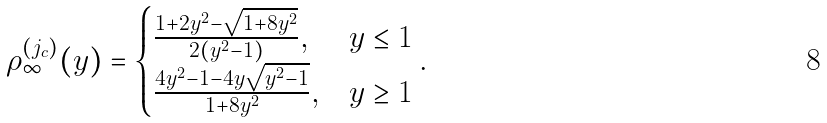<formula> <loc_0><loc_0><loc_500><loc_500>\rho ^ { ( j _ { c } ) } _ { \infty } ( y ) = \begin{cases} \frac { 1 + 2 y ^ { 2 } - \sqrt { 1 + 8 y ^ { 2 } } } { 2 ( y ^ { 2 } - 1 ) } , & y \leq 1 \\ \frac { 4 y ^ { 2 } - 1 - 4 y \sqrt { y ^ { 2 } - 1 } } { 1 + 8 y ^ { 2 } } , & y \geq 1 \end{cases} .</formula> 